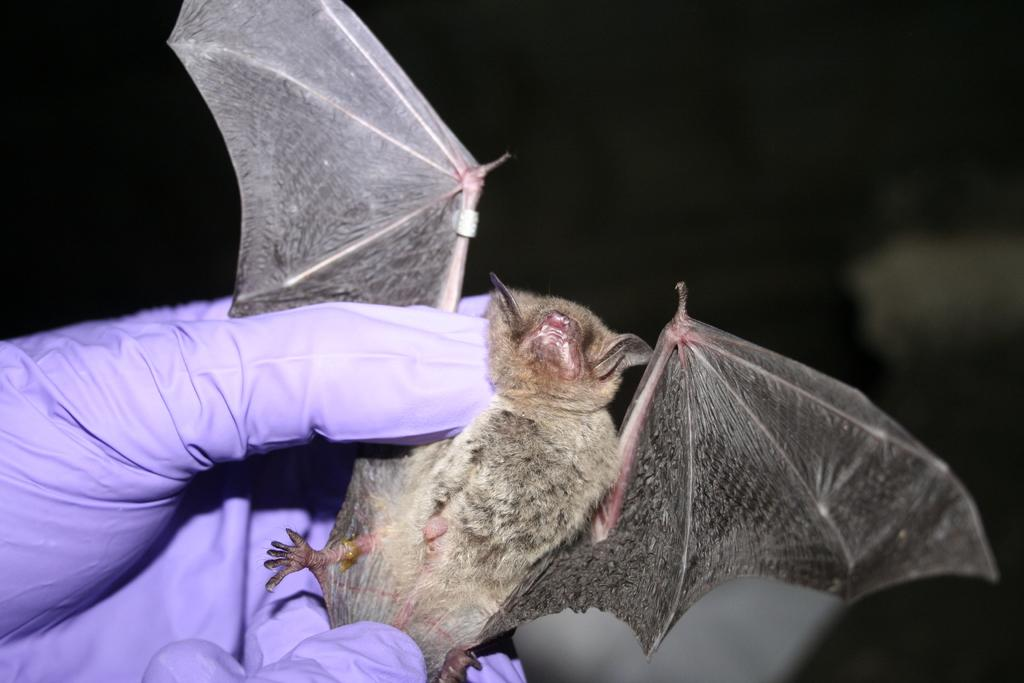What can be seen in the image related to a person? There is a hand of a person in the image. How is the hand dressed in the image? The hand is covered with gloves. What is the hand holding in the image? The hand is holding an animal with wings. What is the color of the background in the image? The background of the image is black. Is there a cough visible in the image? No, there is no cough present in the image. What type of snake can be seen slithering on the table in the image? There is no snake or table present in the image. 